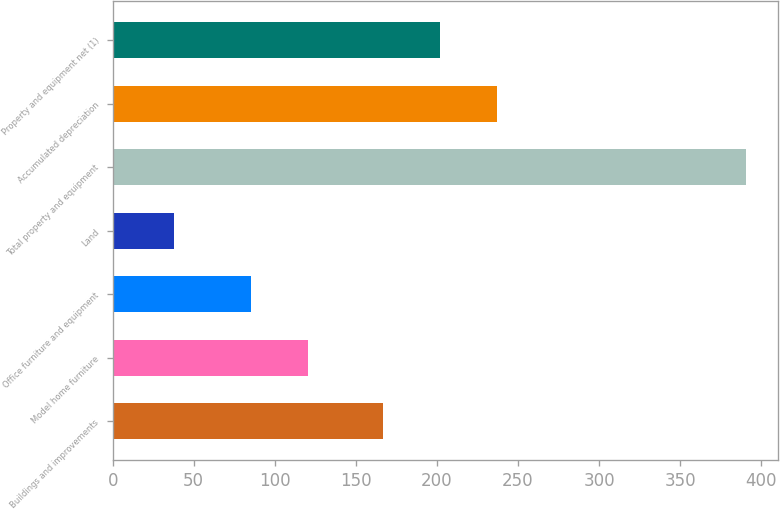<chart> <loc_0><loc_0><loc_500><loc_500><bar_chart><fcel>Buildings and improvements<fcel>Model home furniture<fcel>Office furniture and equipment<fcel>Land<fcel>Total property and equipment<fcel>Accumulated depreciation<fcel>Property and equipment net (1)<nl><fcel>166.7<fcel>120.71<fcel>85.4<fcel>37.8<fcel>390.9<fcel>237.32<fcel>202.01<nl></chart> 